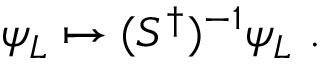Convert formula to latex. <formula><loc_0><loc_0><loc_500><loc_500>\psi _ { L } \mapsto ( S ^ { \dagger } ) ^ { - 1 } \psi _ { L } .</formula> 